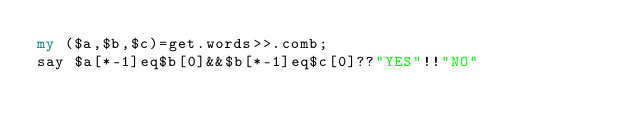<code> <loc_0><loc_0><loc_500><loc_500><_Perl_>my ($a,$b,$c)=get.words>>.comb;
say $a[*-1]eq$b[0]&&$b[*-1]eq$c[0]??"YES"!!"NO"</code> 